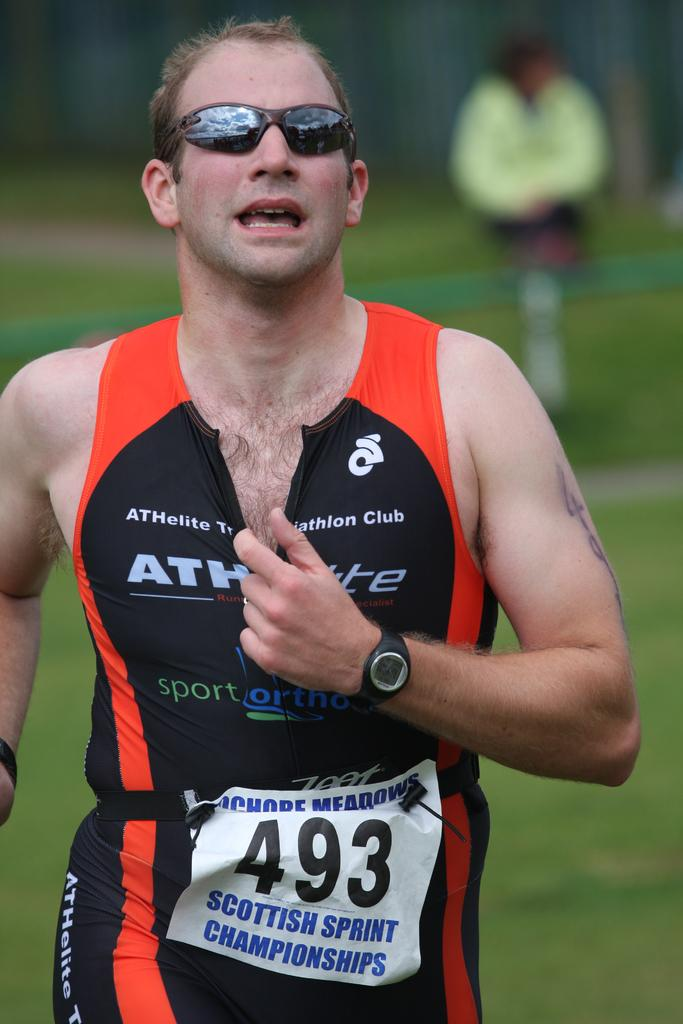<image>
Relay a brief, clear account of the picture shown. Man running on track and field, he is part of the Scottish Sprint Championships # 493. 